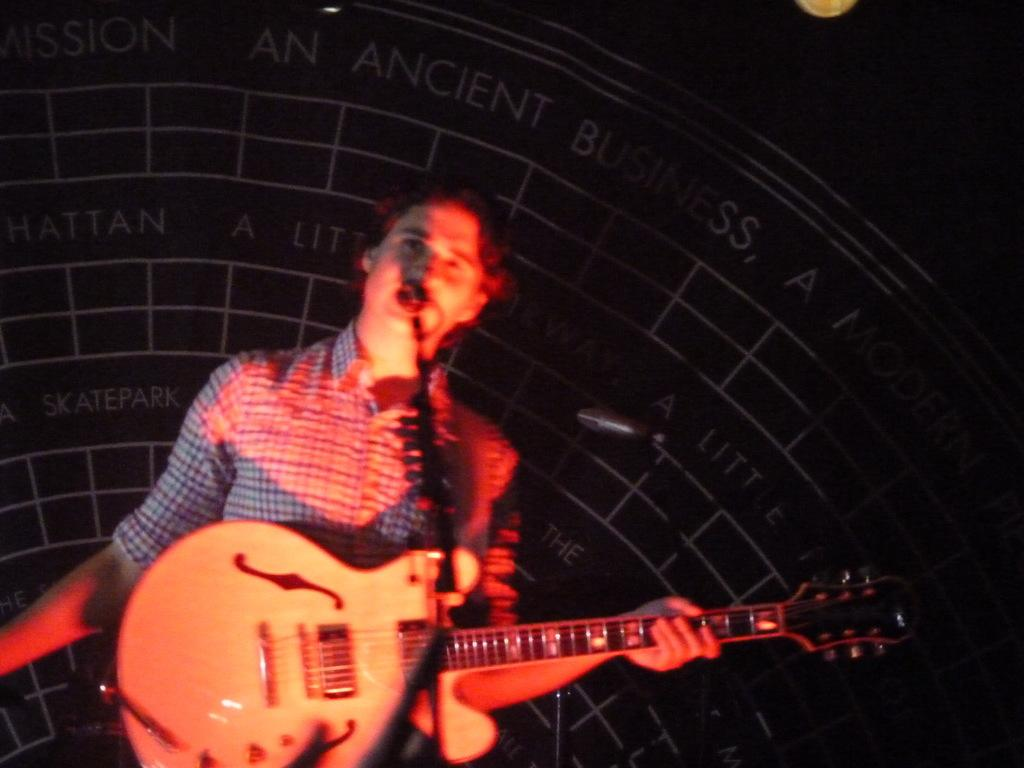What is the main subject of the image? There is a person in the image. What is the person holding in the image? The person is holding a guitar. What type of building can be seen in the background of the image? There is no building visible in the image; it only features a person holding a guitar. What is the person learning to play in the image? The image does not show the person learning anything; they are simply holding a guitar. 